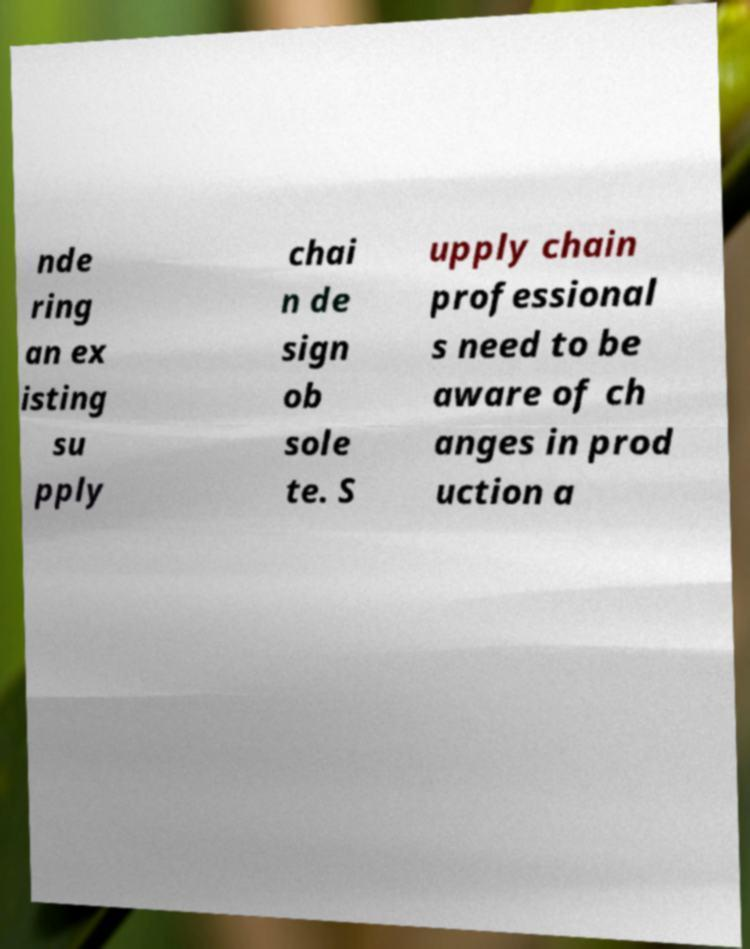Can you read and provide the text displayed in the image?This photo seems to have some interesting text. Can you extract and type it out for me? nde ring an ex isting su pply chai n de sign ob sole te. S upply chain professional s need to be aware of ch anges in prod uction a 